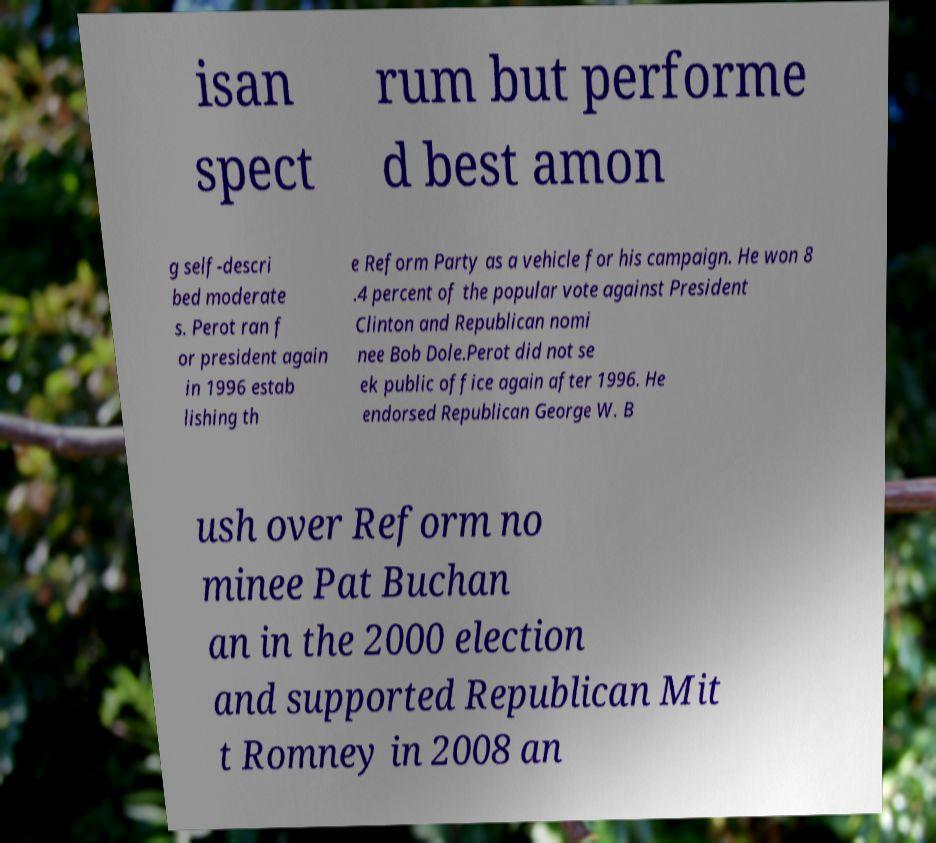Can you read and provide the text displayed in the image?This photo seems to have some interesting text. Can you extract and type it out for me? isan spect rum but performe d best amon g self-descri bed moderate s. Perot ran f or president again in 1996 estab lishing th e Reform Party as a vehicle for his campaign. He won 8 .4 percent of the popular vote against President Clinton and Republican nomi nee Bob Dole.Perot did not se ek public office again after 1996. He endorsed Republican George W. B ush over Reform no minee Pat Buchan an in the 2000 election and supported Republican Mit t Romney in 2008 an 